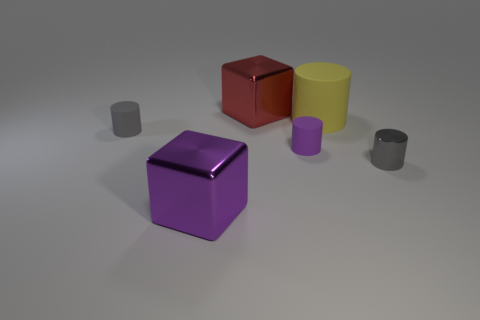Subtract all tiny gray matte cylinders. How many cylinders are left? 3 Subtract all yellow cylinders. How many cylinders are left? 3 Subtract all green cylinders. Subtract all brown spheres. How many cylinders are left? 4 Add 1 gray metal cylinders. How many objects exist? 7 Subtract all cylinders. How many objects are left? 2 Add 4 large shiny objects. How many large shiny objects are left? 6 Add 5 tiny gray metal cylinders. How many tiny gray metal cylinders exist? 6 Subtract 0 green spheres. How many objects are left? 6 Subtract all big red objects. Subtract all red cubes. How many objects are left? 4 